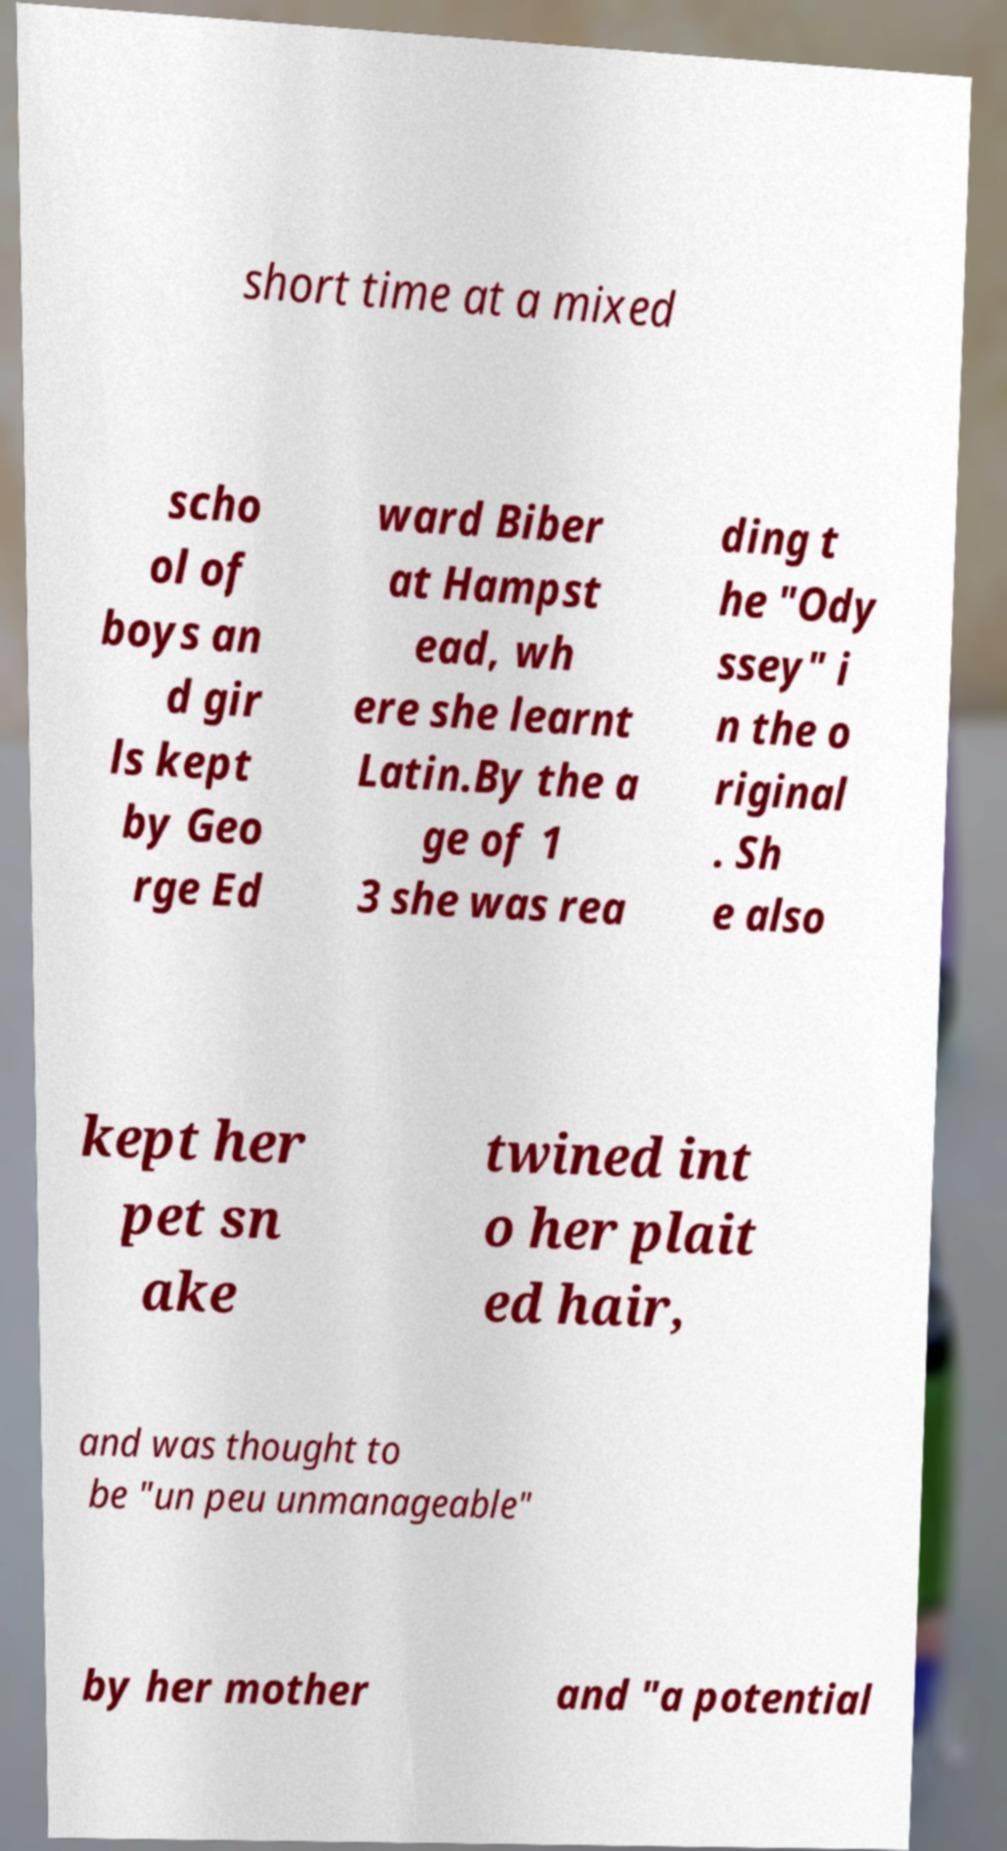Can you accurately transcribe the text from the provided image for me? short time at a mixed scho ol of boys an d gir ls kept by Geo rge Ed ward Biber at Hampst ead, wh ere she learnt Latin.By the a ge of 1 3 she was rea ding t he "Ody ssey" i n the o riginal . Sh e also kept her pet sn ake twined int o her plait ed hair, and was thought to be "un peu unmanageable" by her mother and "a potential 